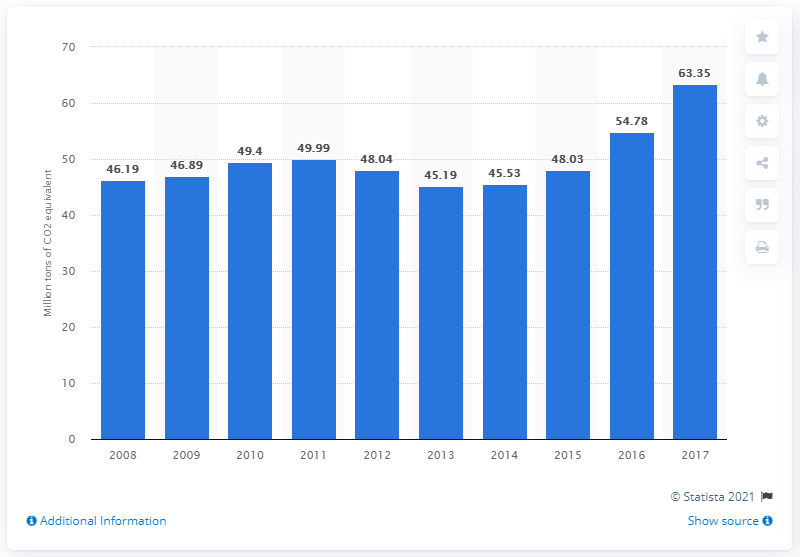Specify some key components in this picture. In 2016, the emissions were 54.78. In 2017, Poland emitted 63.35 megatons of CO2 equivalent from fuel combustion, according to official government records. The average of the initial three years is 47.4. 